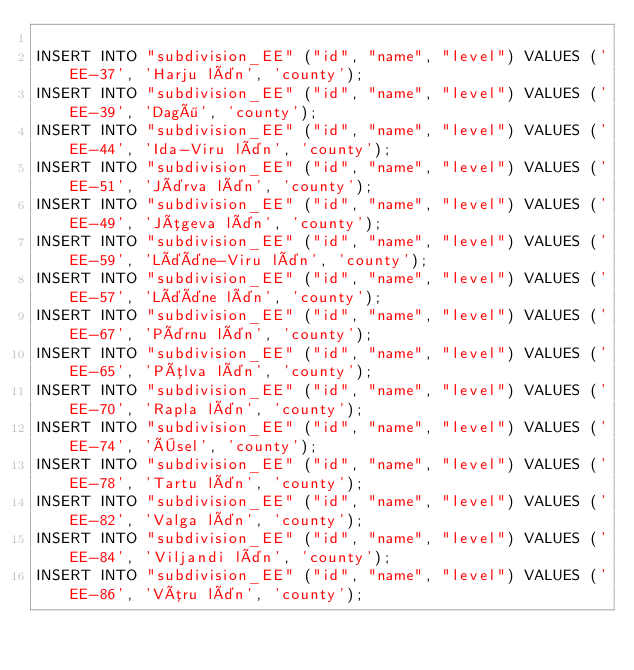Convert code to text. <code><loc_0><loc_0><loc_500><loc_500><_SQL_>
INSERT INTO "subdivision_EE" ("id", "name", "level") VALUES ('EE-37', 'Harju län', 'county');
INSERT INTO "subdivision_EE" ("id", "name", "level") VALUES ('EE-39', 'Dagö', 'county');
INSERT INTO "subdivision_EE" ("id", "name", "level") VALUES ('EE-44', 'Ida-Viru län', 'county');
INSERT INTO "subdivision_EE" ("id", "name", "level") VALUES ('EE-51', 'Järva län', 'county');
INSERT INTO "subdivision_EE" ("id", "name", "level") VALUES ('EE-49', 'Jõgeva län', 'county');
INSERT INTO "subdivision_EE" ("id", "name", "level") VALUES ('EE-59', 'Lääne-Viru län', 'county');
INSERT INTO "subdivision_EE" ("id", "name", "level") VALUES ('EE-57', 'Lääne län', 'county');
INSERT INTO "subdivision_EE" ("id", "name", "level") VALUES ('EE-67', 'Pärnu län', 'county');
INSERT INTO "subdivision_EE" ("id", "name", "level") VALUES ('EE-65', 'Põlva län', 'county');
INSERT INTO "subdivision_EE" ("id", "name", "level") VALUES ('EE-70', 'Rapla län', 'county');
INSERT INTO "subdivision_EE" ("id", "name", "level") VALUES ('EE-74', 'Ösel', 'county');
INSERT INTO "subdivision_EE" ("id", "name", "level") VALUES ('EE-78', 'Tartu län', 'county');
INSERT INTO "subdivision_EE" ("id", "name", "level") VALUES ('EE-82', 'Valga län', 'county');
INSERT INTO "subdivision_EE" ("id", "name", "level") VALUES ('EE-84', 'Viljandi län', 'county');
INSERT INTO "subdivision_EE" ("id", "name", "level") VALUES ('EE-86', 'Võru län', 'county');
</code> 